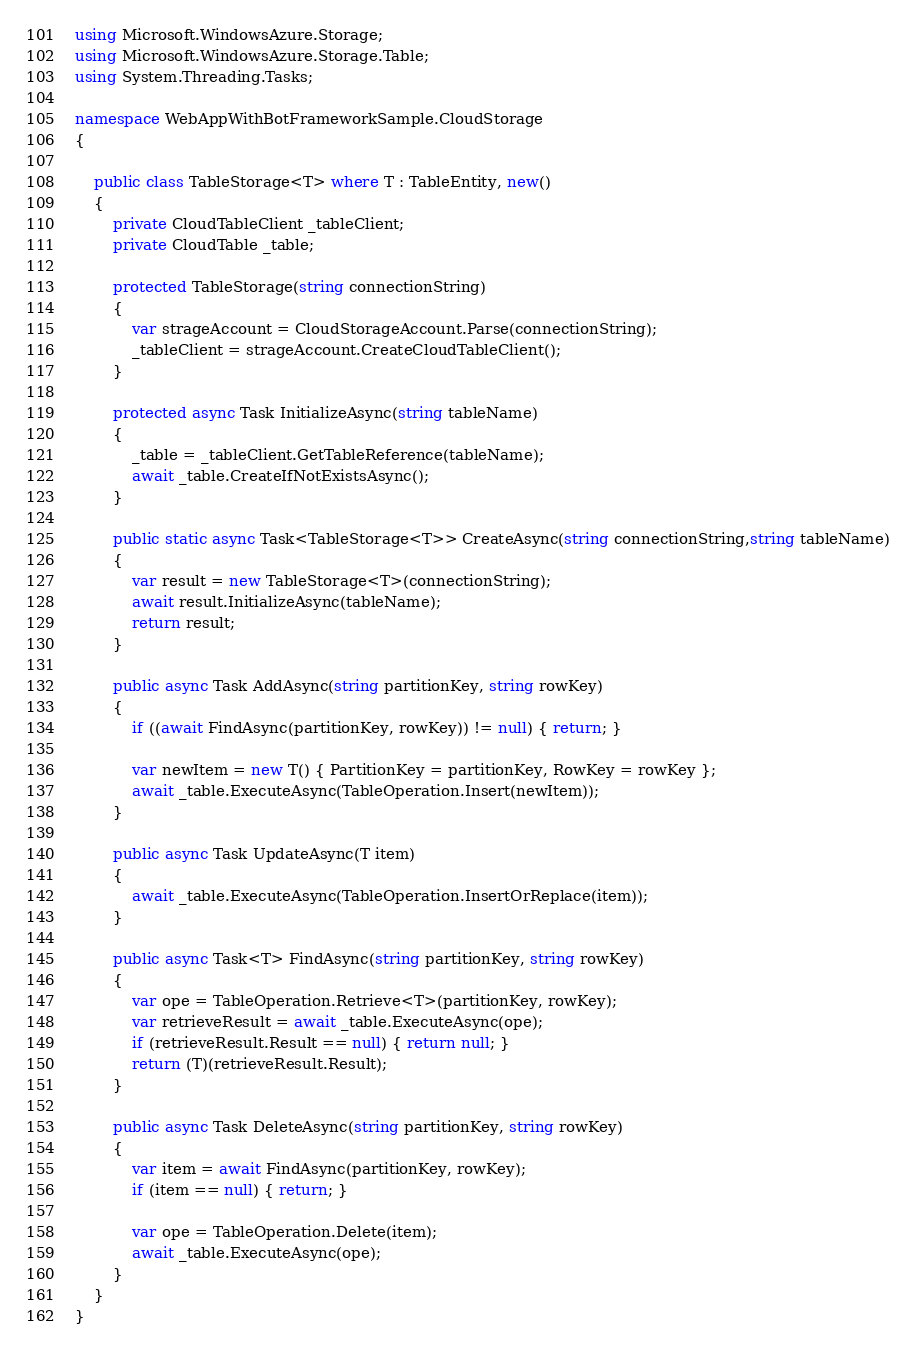<code> <loc_0><loc_0><loc_500><loc_500><_C#_>using Microsoft.WindowsAzure.Storage;
using Microsoft.WindowsAzure.Storage.Table;
using System.Threading.Tasks;

namespace WebAppWithBotFrameworkSample.CloudStorage
{

    public class TableStorage<T> where T : TableEntity, new()
    {
        private CloudTableClient _tableClient;
        private CloudTable _table;

        protected TableStorage(string connectionString)
        {
            var strageAccount = CloudStorageAccount.Parse(connectionString);
            _tableClient = strageAccount.CreateCloudTableClient();
        }

        protected async Task InitializeAsync(string tableName)
        {
            _table = _tableClient.GetTableReference(tableName);
            await _table.CreateIfNotExistsAsync();
        }

        public static async Task<TableStorage<T>> CreateAsync(string connectionString,string tableName)
        {
            var result = new TableStorage<T>(connectionString);
            await result.InitializeAsync(tableName);
            return result;
        }

        public async Task AddAsync(string partitionKey, string rowKey)
        {
            if ((await FindAsync(partitionKey, rowKey)) != null) { return; }

            var newItem = new T() { PartitionKey = partitionKey, RowKey = rowKey };
            await _table.ExecuteAsync(TableOperation.Insert(newItem));
        }

        public async Task UpdateAsync(T item)
        {
            await _table.ExecuteAsync(TableOperation.InsertOrReplace(item));
        }

        public async Task<T> FindAsync(string partitionKey, string rowKey)
        {
            var ope = TableOperation.Retrieve<T>(partitionKey, rowKey);
            var retrieveResult = await _table.ExecuteAsync(ope);
            if (retrieveResult.Result == null) { return null; }
            return (T)(retrieveResult.Result);
        }

        public async Task DeleteAsync(string partitionKey, string rowKey)
        {
            var item = await FindAsync(partitionKey, rowKey);
            if (item == null) { return; }

            var ope = TableOperation.Delete(item);
            await _table.ExecuteAsync(ope);
        }
    }
}
</code> 